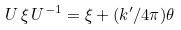<formula> <loc_0><loc_0><loc_500><loc_500>U \, \xi \, U ^ { - 1 } = \xi + ( k ^ { \prime } / 4 \pi ) \theta</formula> 